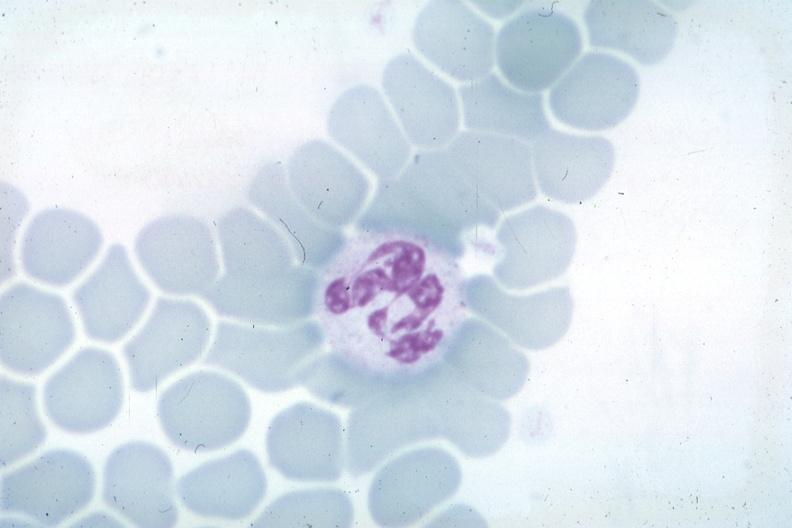what is wrights not the best photograph for color but nuclear change unknown?
Answer the question using a single word or phrase. Obvious source 